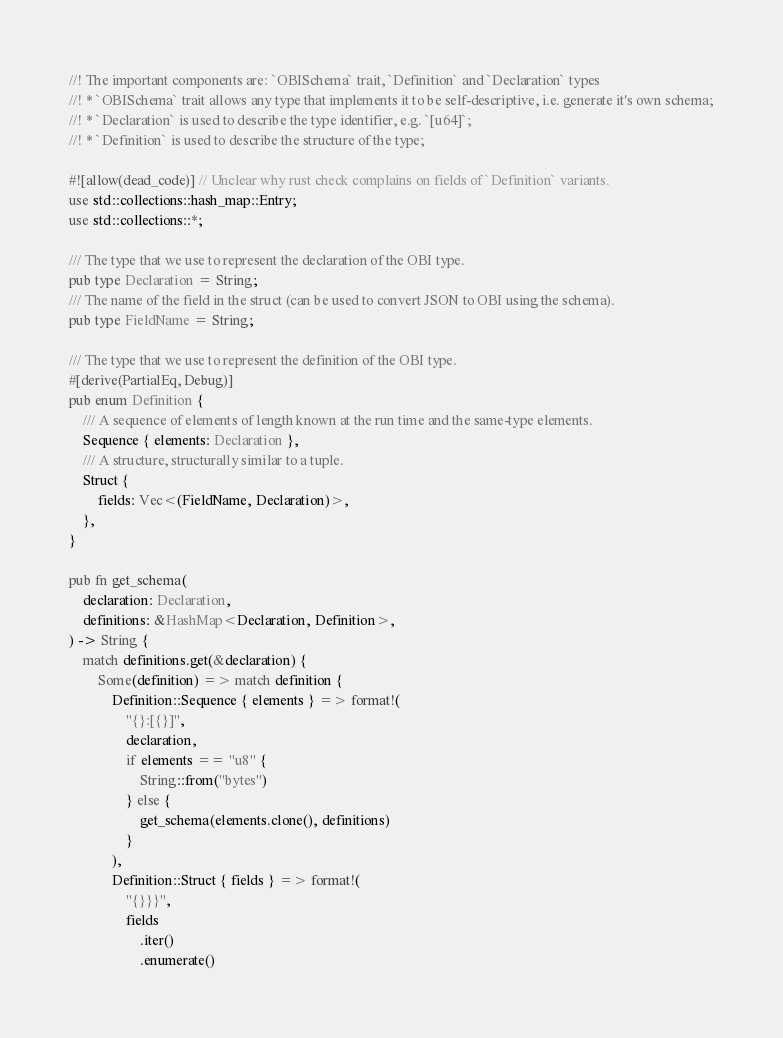<code> <loc_0><loc_0><loc_500><loc_500><_Rust_>//! The important components are: `OBISchema` trait, `Definition` and `Declaration` types
//! * `OBISchema` trait allows any type that implements it to be self-descriptive, i.e. generate it's own schema;
//! * `Declaration` is used to describe the type identifier, e.g. `[u64]`;
//! * `Definition` is used to describe the structure of the type;

#![allow(dead_code)] // Unclear why rust check complains on fields of `Definition` variants.
use std::collections::hash_map::Entry;
use std::collections::*;

/// The type that we use to represent the declaration of the OBI type.
pub type Declaration = String;
/// The name of the field in the struct (can be used to convert JSON to OBI using the schema).
pub type FieldName = String;

/// The type that we use to represent the definition of the OBI type.
#[derive(PartialEq, Debug)]
pub enum Definition {
    /// A sequence of elements of length known at the run time and the same-type elements.
    Sequence { elements: Declaration },
    /// A structure, structurally similar to a tuple.
    Struct {
        fields: Vec<(FieldName, Declaration)>,
    },
}

pub fn get_schema(
    declaration: Declaration,
    definitions: &HashMap<Declaration, Definition>,
) -> String {
    match definitions.get(&declaration) {
        Some(definition) => match definition {
            Definition::Sequence { elements } => format!(
                "{}:[{}]",
                declaration,
                if elements == "u8" {
                    String::from("bytes")
                } else {
                    get_schema(elements.clone(), definitions)
                }
            ),
            Definition::Struct { fields } => format!(
                "{}}}",
                fields
                    .iter()
                    .enumerate()</code> 